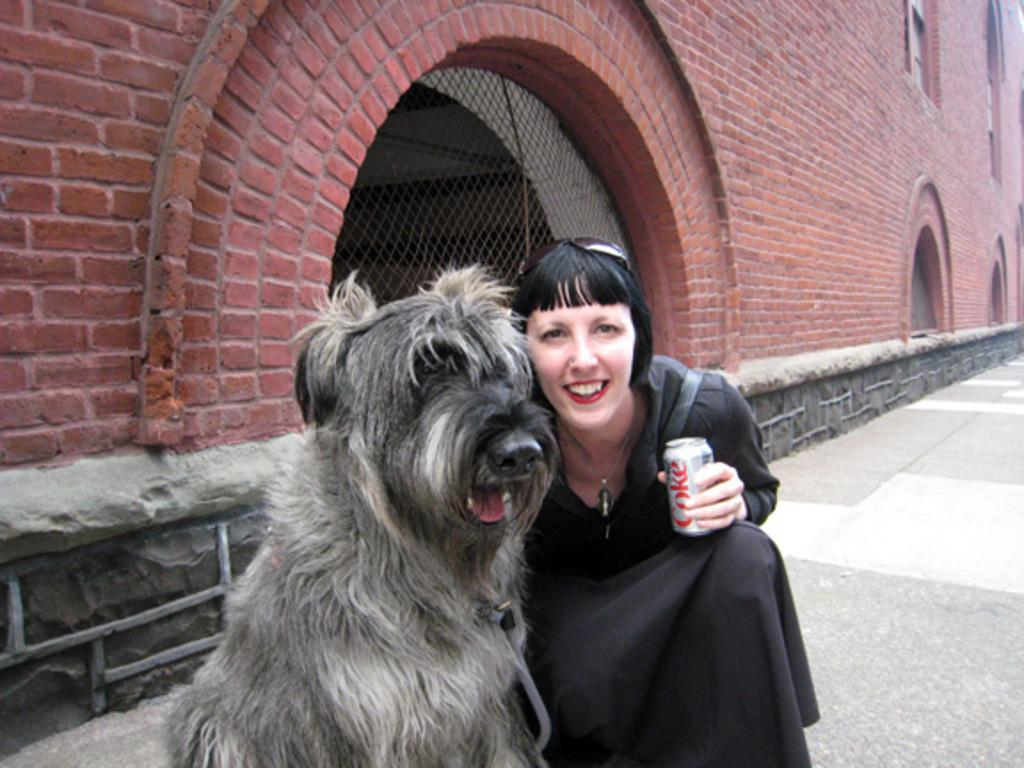What is the person in the image doing? The person is sitting in the image. What is the person's facial expression? The person is smiling. What is the person holding in the image? The person is holding a coke tin. Is there any other living creature in the image besides the person? Yes, there is a dog beside the person. What can be seen in the background of the image? There is a building in the background of the image. Where is the lake located in the image? There is no lake present in the image. How many kittens are playing with the dog in the image? There are no kittens present in the image; only a dog is visible beside the person. 